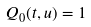Convert formula to latex. <formula><loc_0><loc_0><loc_500><loc_500>Q _ { 0 } ( t , u ) = 1</formula> 